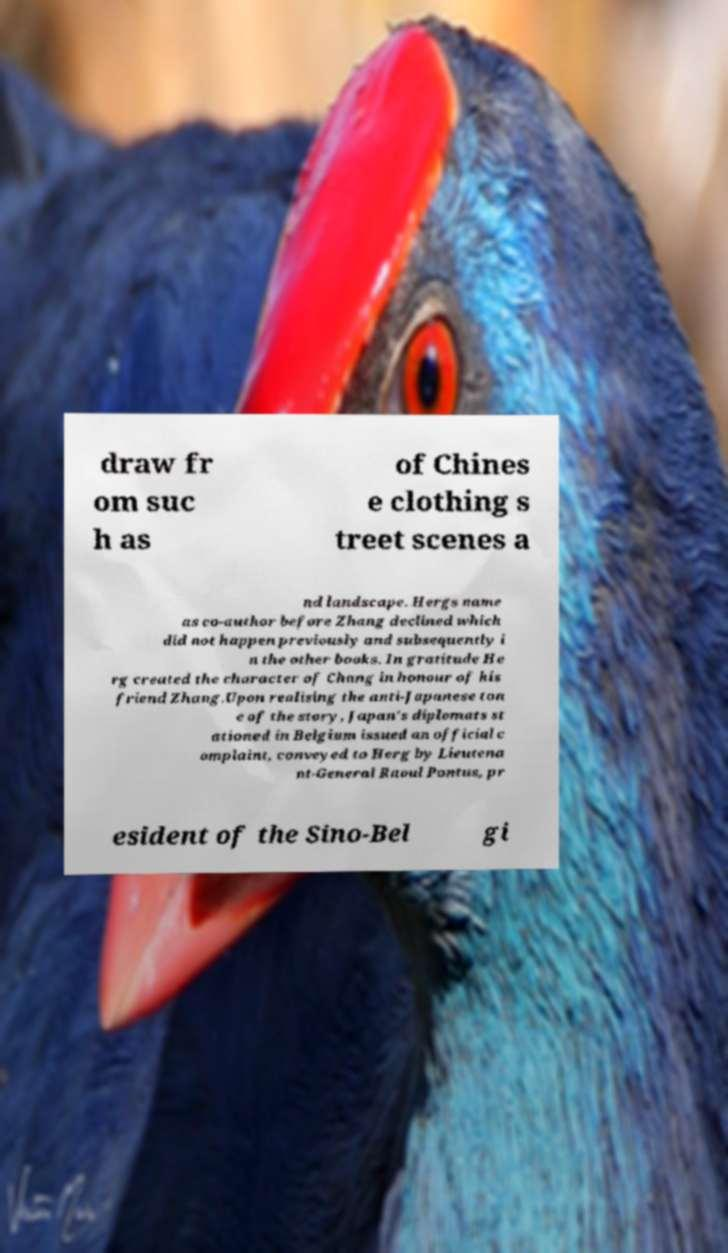Could you extract and type out the text from this image? draw fr om suc h as of Chines e clothing s treet scenes a nd landscape. Hergs name as co-author before Zhang declined which did not happen previously and subsequently i n the other books. In gratitude He rg created the character of Chang in honour of his friend Zhang.Upon realising the anti-Japanese ton e of the story, Japan's diplomats st ationed in Belgium issued an official c omplaint, conveyed to Herg by Lieutena nt-General Raoul Pontus, pr esident of the Sino-Bel gi 